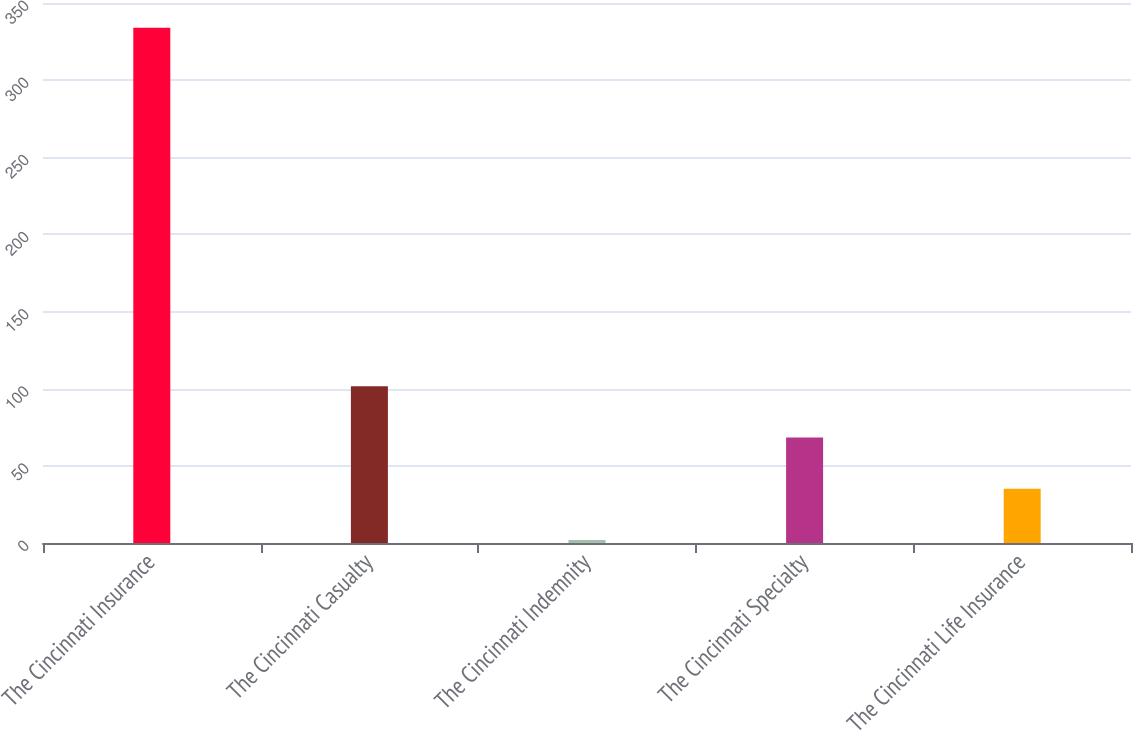<chart> <loc_0><loc_0><loc_500><loc_500><bar_chart><fcel>The Cincinnati Insurance<fcel>The Cincinnati Casualty<fcel>The Cincinnati Indemnity<fcel>The Cincinnati Specialty<fcel>The Cincinnati Life Insurance<nl><fcel>334<fcel>101.6<fcel>2<fcel>68.4<fcel>35.2<nl></chart> 